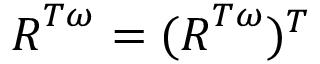Convert formula to latex. <formula><loc_0><loc_0><loc_500><loc_500>R ^ { T \omega } = ( R ^ { T \omega } ) ^ { T }</formula> 